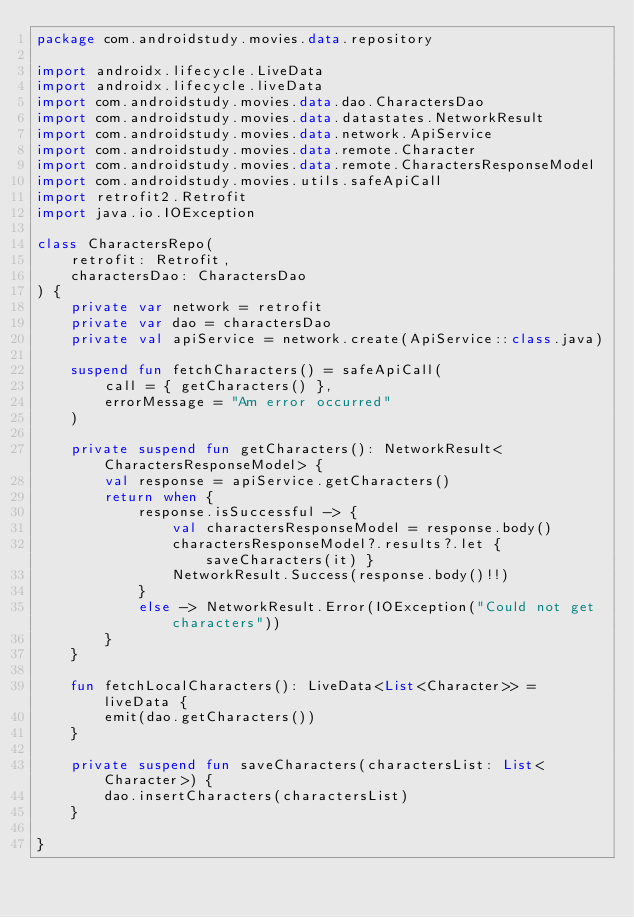Convert code to text. <code><loc_0><loc_0><loc_500><loc_500><_Kotlin_>package com.androidstudy.movies.data.repository

import androidx.lifecycle.LiveData
import androidx.lifecycle.liveData
import com.androidstudy.movies.data.dao.CharactersDao
import com.androidstudy.movies.data.datastates.NetworkResult
import com.androidstudy.movies.data.network.ApiService
import com.androidstudy.movies.data.remote.Character
import com.androidstudy.movies.data.remote.CharactersResponseModel
import com.androidstudy.movies.utils.safeApiCall
import retrofit2.Retrofit
import java.io.IOException

class CharactersRepo(
    retrofit: Retrofit,
    charactersDao: CharactersDao
) {
    private var network = retrofit
    private var dao = charactersDao
    private val apiService = network.create(ApiService::class.java)

    suspend fun fetchCharacters() = safeApiCall(
        call = { getCharacters() },
        errorMessage = "Am error occurred"
    )

    private suspend fun getCharacters(): NetworkResult<CharactersResponseModel> {
        val response = apiService.getCharacters()
        return when {
            response.isSuccessful -> {
                val charactersResponseModel = response.body()
                charactersResponseModel?.results?.let { saveCharacters(it) }
                NetworkResult.Success(response.body()!!)
            }
            else -> NetworkResult.Error(IOException("Could not get characters"))
        }
    }

    fun fetchLocalCharacters(): LiveData<List<Character>> = liveData {
        emit(dao.getCharacters())
    }

    private suspend fun saveCharacters(charactersList: List<Character>) {
        dao.insertCharacters(charactersList)
    }

}</code> 